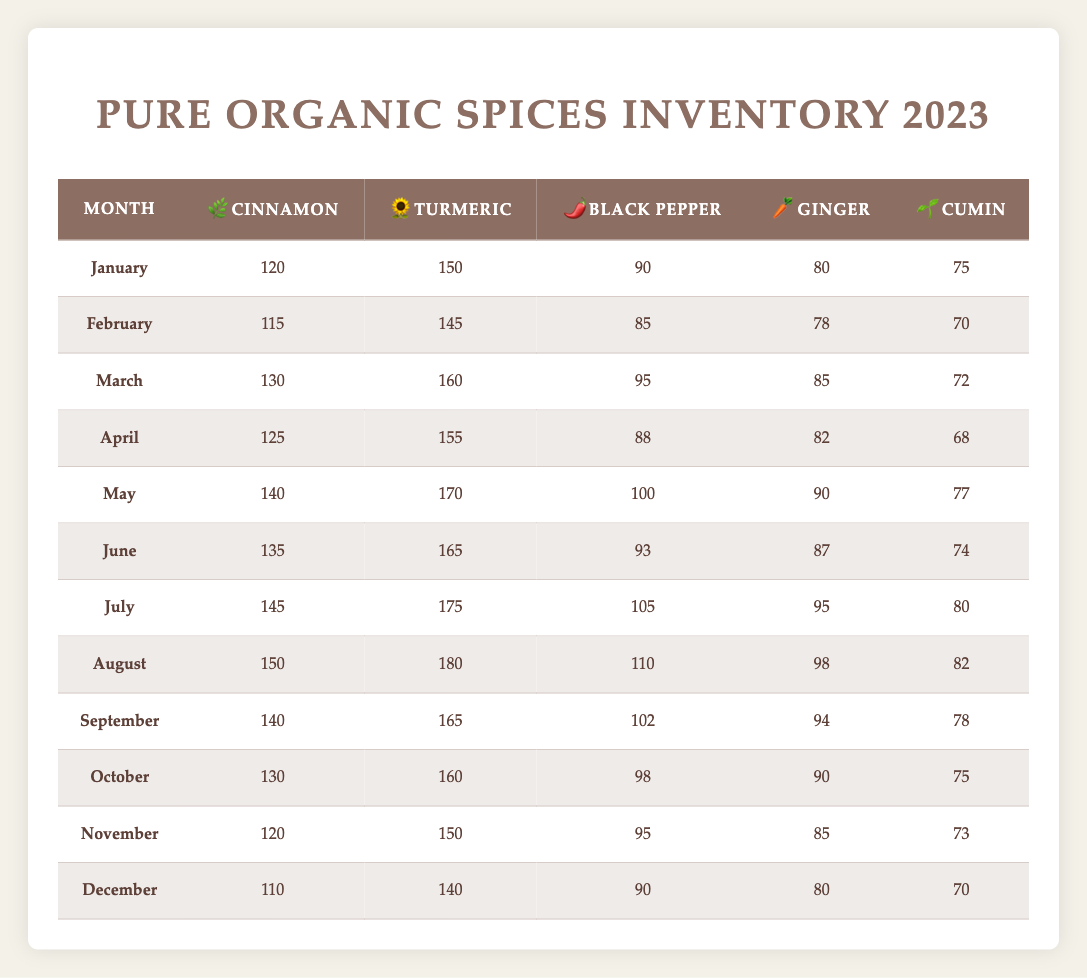What is the highest inventory level of turmeric in 2023? The highest inventory level of turmeric is found by scanning through the turmeric column in each month. The maximum value is 180 in August.
Answer: 180 What is the lowest inventory level of cumin recorded in the year? By checking the cumin column, the lowest value is found in April, which is 68.
Answer: 68 Which month had the highest black pepper inventory, and what was the amount? Looking through the black pepper column for the maximum value, July has the highest black pepper inventory with a value of 105.
Answer: July, 105 What is the total inventory of cinnamon from January to June? To find this total, we need to sum the values from January to June: 120 + 115 + 130 + 125 + 140 + 135 = 765.
Answer: 765 Is the cumulative inventory level of ginger for the first half of the year (January to June) greater than that for the second half (July to December)? First, calculate the total for the first half: 80 + 78 + 85 + 82 + 90 + 87 = 502. Then, calculate the second half: 95 + 98 + 94 + 90 + 85 + 80 = 542. Since 502 < 542, the answer is no.
Answer: No What is the average inventory level of turmeric for the year? To get the average, sum all the turmeric values: 150 + 145 + 160 + 155 + 170 + 165 + 175 + 180 + 165 + 160 + 150 + 140 = 1915, and then divide by 12 (the number of months): 1915 / 12 ≈ 159.58.
Answer: 159.58 In which month did the inventory for ginger exceed 90? Reviewing the ginger column, the months where ginger inventory exceeded 90 are May (90), July (95), and August (98); thus, the months are July and August.
Answer: July, August Which spice showed the most consistent inventory levels throughout the year? To determine consistency, we look for the smallest difference between maximum and minimum values. Cumin shows less fluctuation with a range from 68 to 80. The range is small: 80 - 68 = 12.
Answer: Cumin Was the inventory of black pepper consistently above 90 for most months? Looking at the black pepper values: January (90), February (85), March (95), April (88), May (100), June (93), July (105), August (110), September (102), October (98), November (95), December (90). It fell below 90 only in February, April, and no months were below 90 besides those. Hence, the answer is yes.
Answer: Yes 